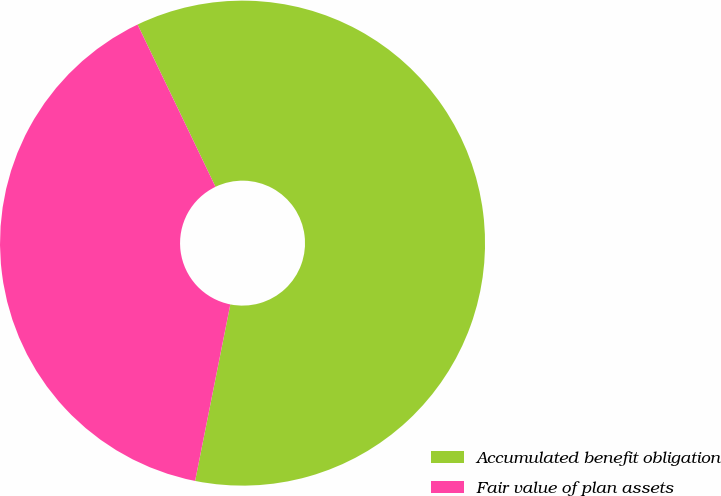Convert chart. <chart><loc_0><loc_0><loc_500><loc_500><pie_chart><fcel>Accumulated benefit obligation<fcel>Fair value of plan assets<nl><fcel>60.26%<fcel>39.74%<nl></chart> 